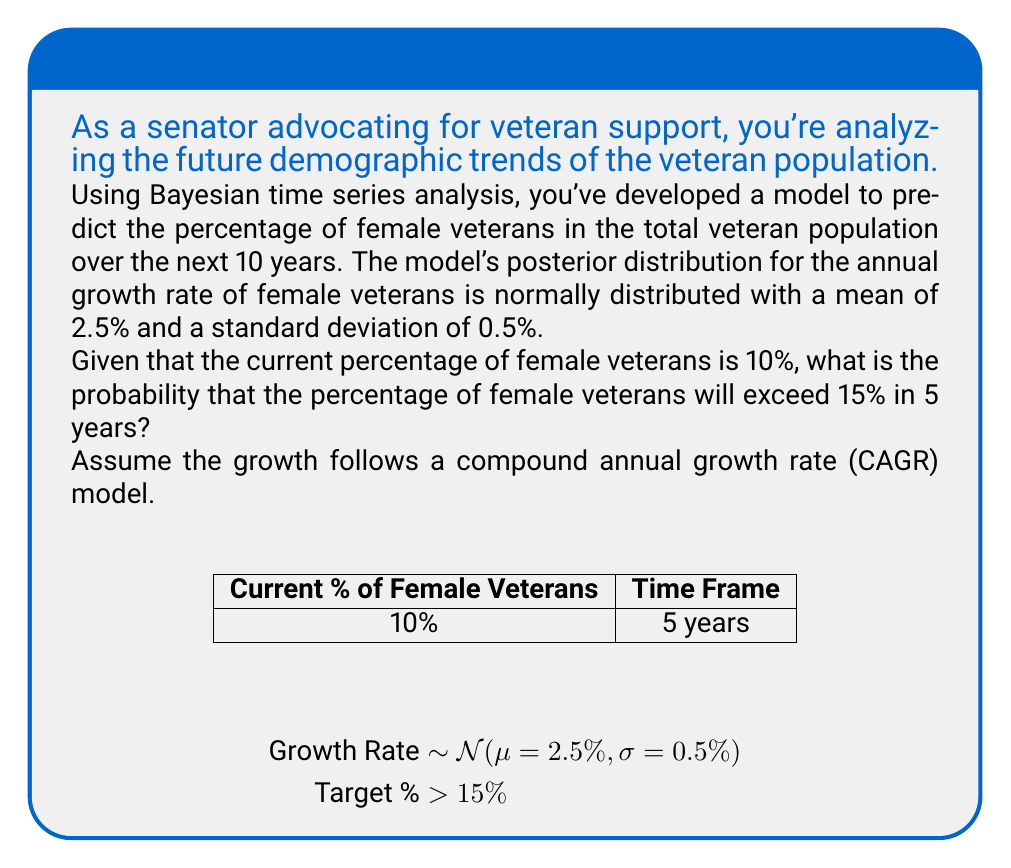What is the answer to this math problem? Let's approach this step-by-step using Bayesian analysis:

1) First, we need to calculate the future value given the growth rate. The formula for compound annual growth rate is:

   $$ FV = PV(1 + r)^t $$

   Where FV is future value, PV is present value, r is growth rate, and t is time in years.

2) In this case, PV = 10%, t = 5 years, and r follows a normal distribution with mean 2.5% and standard deviation 0.5%.

3) We want to find P(FV > 15%). This is equivalent to finding:

   $$ P(10(1 + r)^5 > 15) $$

4) Solving for r:

   $$ 10(1 + r)^5 > 15 $$
   $$ (1 + r)^5 > 1.5 $$
   $$ 1 + r > 1.5^{1/5} $$
   $$ r > 1.5^{1/5} - 1 \approx 0.0845 $$

5) So, we need to find P(r > 0.0845) where r ~ N(0.025, 0.005^2)

6) We can standardize this:

   $$ z = \frac{0.0845 - 0.025}{0.005} = 11.9 $$

7) Using the standard normal distribution, we need to find:

   $$ P(Z > 11.9) = 1 - \Phi(11.9) $$

   Where Φ is the cumulative distribution function of the standard normal distribution.

8) This probability is extremely small, effectively zero to many decimal places.
Answer: Effectively 0 